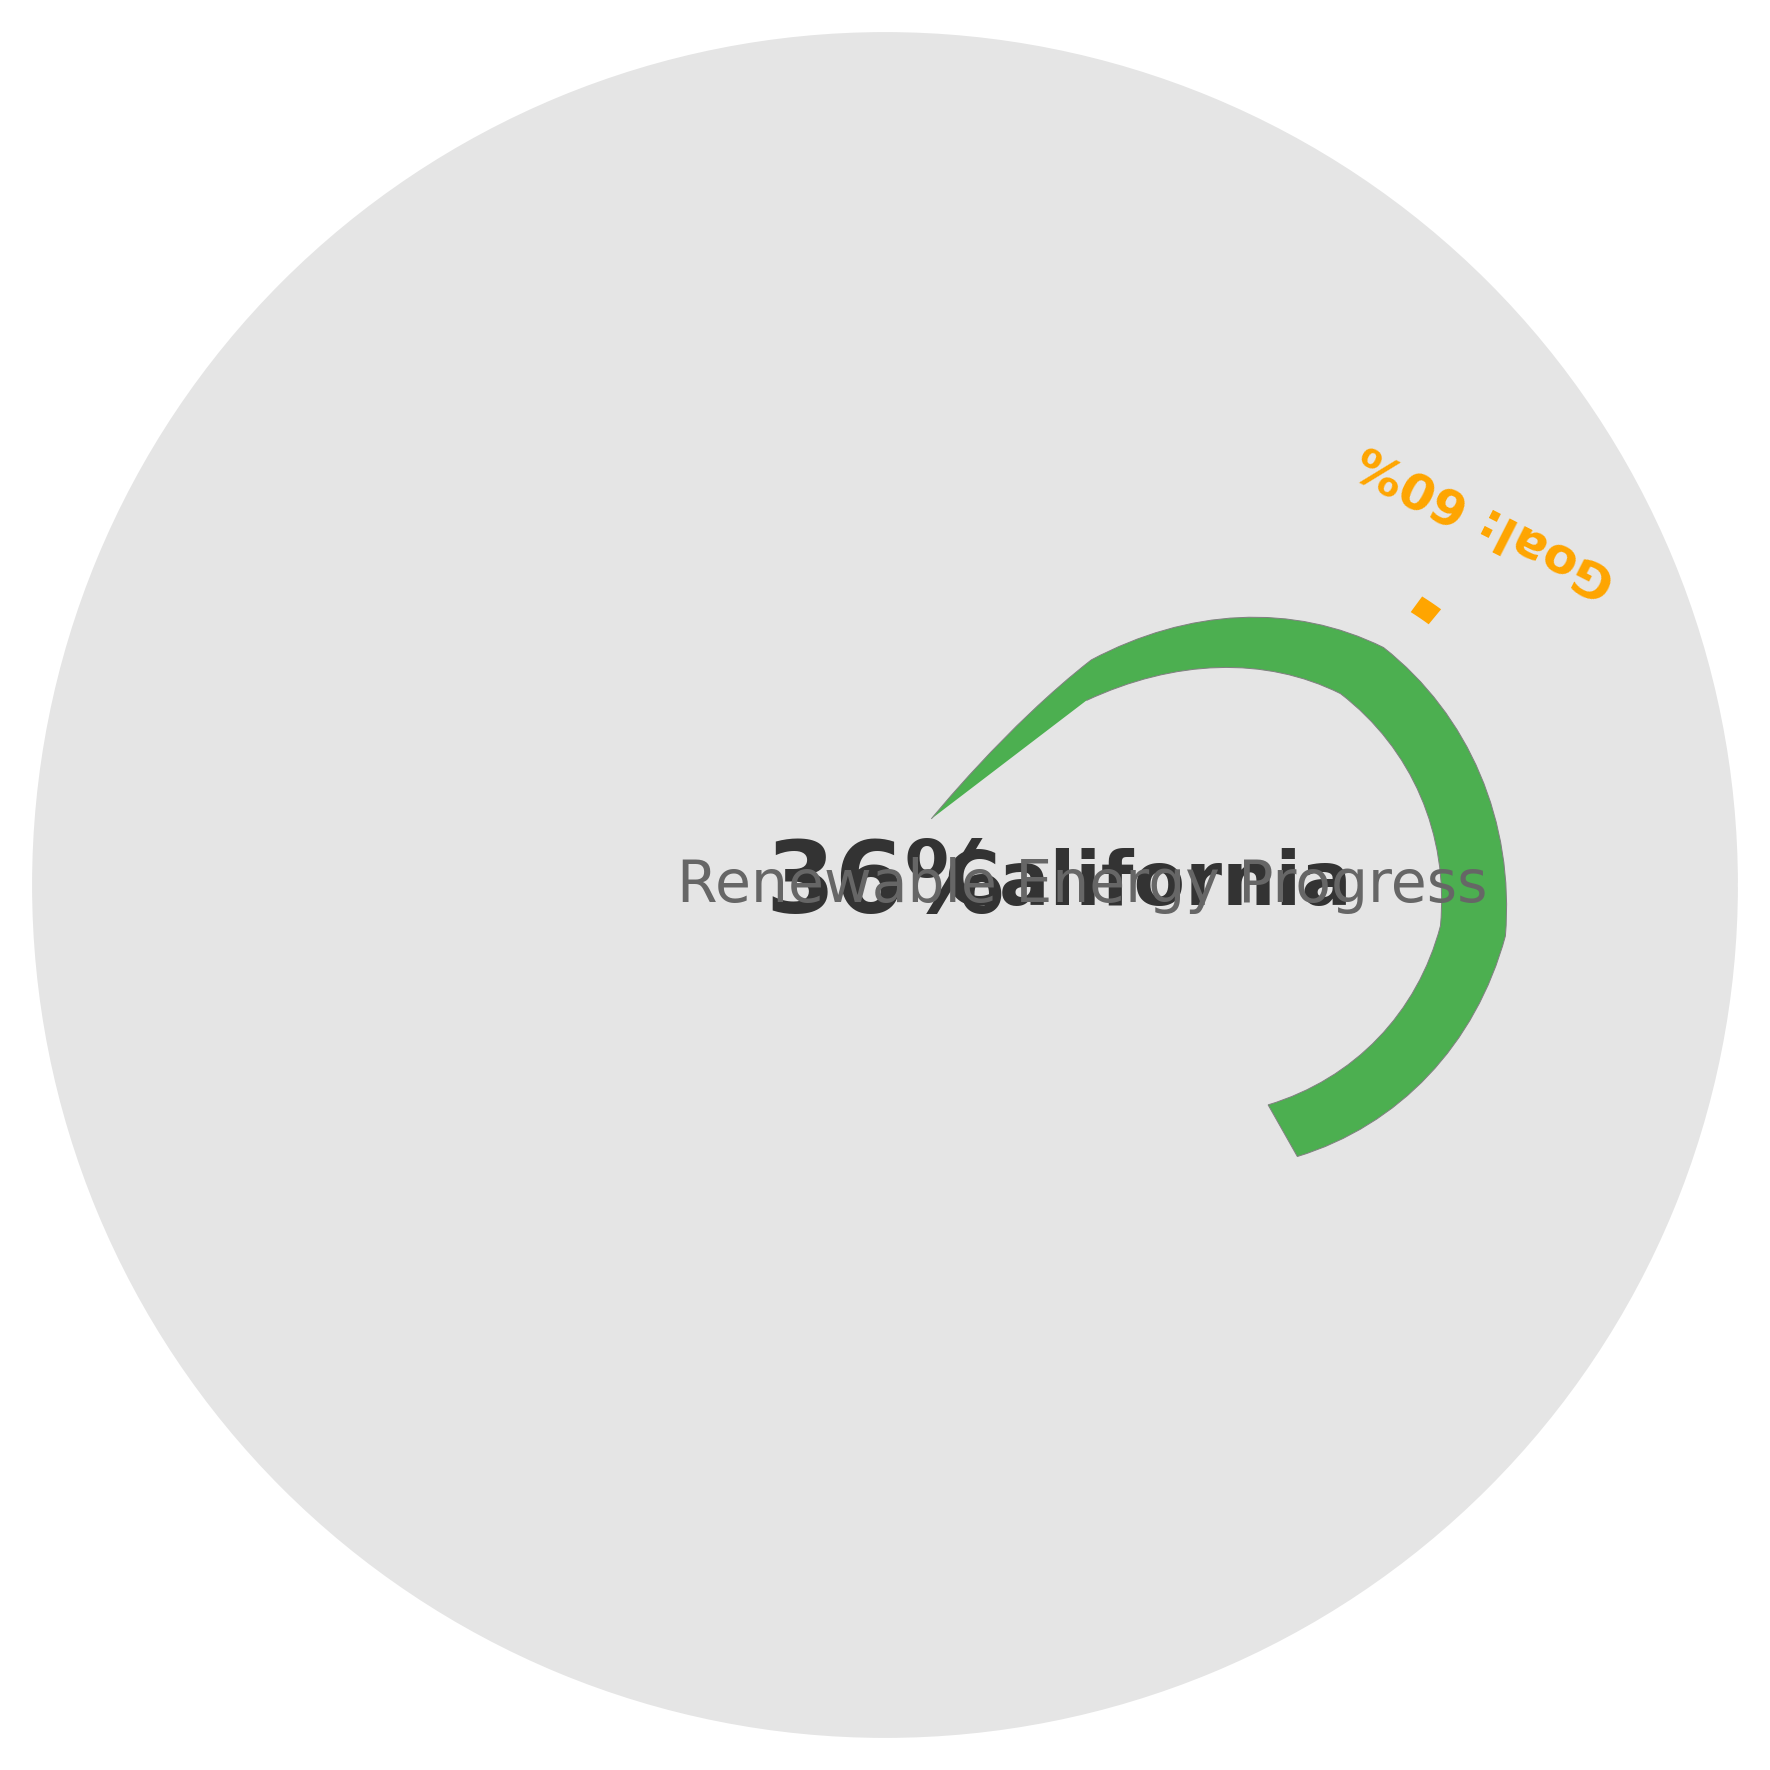What is the current renewable energy percentage in California? The gauge chart shows the current renewable energy percentage prominently in the center with the text "36%".
Answer: 36% What is the renewable energy goal for California? The goal is indicated by a marker and the text "Goal: 60%" outside the circumference of the gauge.
Answer: 60% How many percentage points does California need to increase to reach its renewable energy goal? The difference between the goal (60%) and the current percentage (36%) needs to be calculated: 60 - 36 = 24.
Answer: 24 Considering the circular gauge, towards which side does the needle point more, the left or the right? The gauge starts from the left at 225 degrees, moving clockwise. The needle points to the right side as the progress is toward end-angle -45 from the starting angle.
Answer: Right Which colors are used to represent the gauge and the goal marker, respectively? The gauge is represented in a green color, and the goal marker is in orange. These colors are easily distinguishable on the chart.
Answer: Green, Orange 